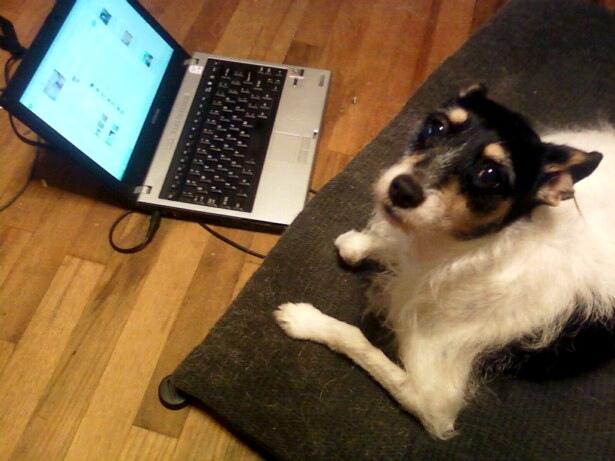Where is the mat?
Answer briefly. Floor. What is this dog sitting in?
Answer briefly. Pillow. What animals are depicted?
Short answer required. Dog. Is the dog laying in a dog bed?
Write a very short answer. Yes. Where is the dog?
Concise answer only. On pillow. What kind of animal is this?
Keep it brief. Dog. What is the rectangular object in the floor?
Be succinct. Laptop. Does this animal like to lay in boxes?
Quick response, please. No. Is the dog looking at the camera?
Concise answer only. Yes. Is the cat an inside cat?
Concise answer only. No. What is the dog eating?
Concise answer only. Nothing. How many cats?
Quick response, please. 0. What brand of computer is this?
Answer briefly. Dell. Who appears to be using the computer?
Concise answer only. Dog. Does the dog want to learn how to type?
Be succinct. No. How many monitors?
Give a very brief answer. 1. What has tiles?
Be succinct. Floor. Is the dog playing with a stuffed animal?
Be succinct. No. What is on the floor next to the dog?
Quick response, please. Laptop. What color is the dog?
Keep it brief. White. Is that a real dog bone?
Answer briefly. No. What breed is the dog?
Short answer required. Terrier. Eyes, of a cat?
Quick response, please. No. 